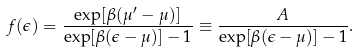<formula> <loc_0><loc_0><loc_500><loc_500>f ( \epsilon ) = \frac { \exp [ \beta ( \mu ^ { \prime } - \mu ) ] } { \exp [ \beta ( \epsilon - \mu ) ] - 1 } \equiv \frac { A } { \exp [ \beta ( \epsilon - \mu ) ] - 1 } .</formula> 